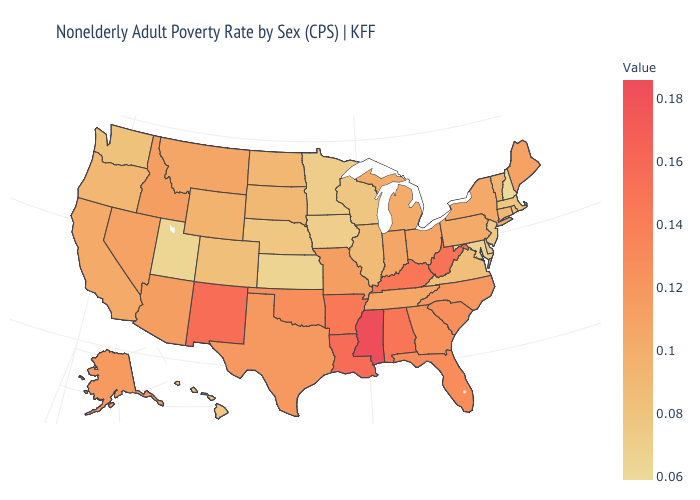Which states have the highest value in the USA?
Short answer required. Mississippi. Does Maine have a lower value than South Carolina?
Short answer required. Yes. Does North Dakota have a lower value than Delaware?
Concise answer only. No. Does Utah have the lowest value in the West?
Give a very brief answer. Yes. Among the states that border Missouri , which have the highest value?
Quick response, please. Kentucky. 